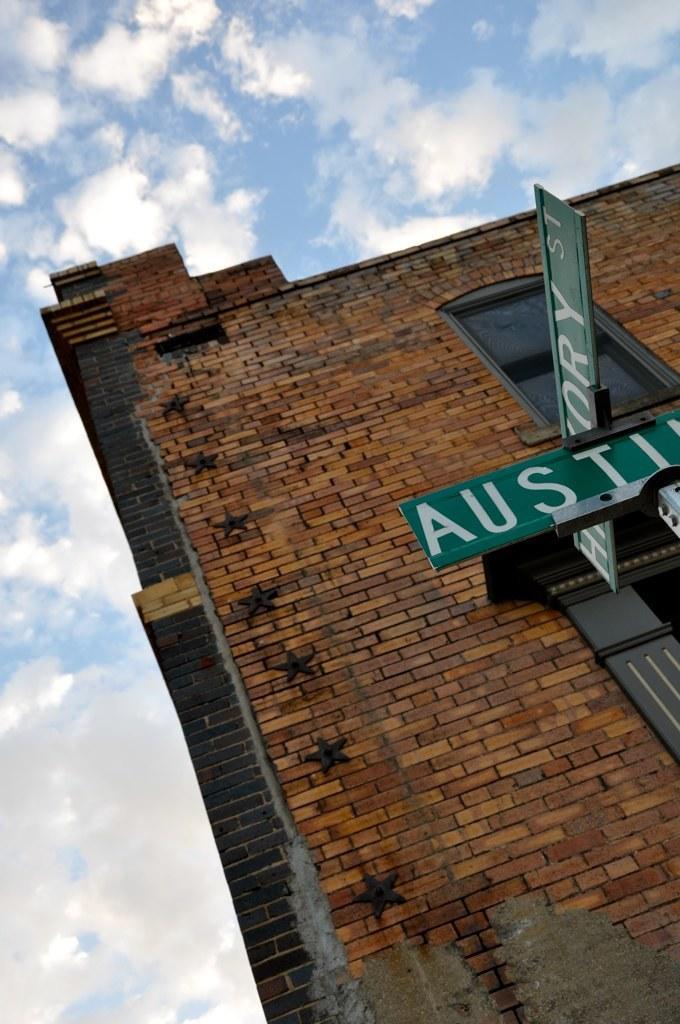Describe this image in one or two sentences. In front of the image there are boards with some text on it. Behind the boards, there is a building. At the top of the image there are clouds in the sky. 